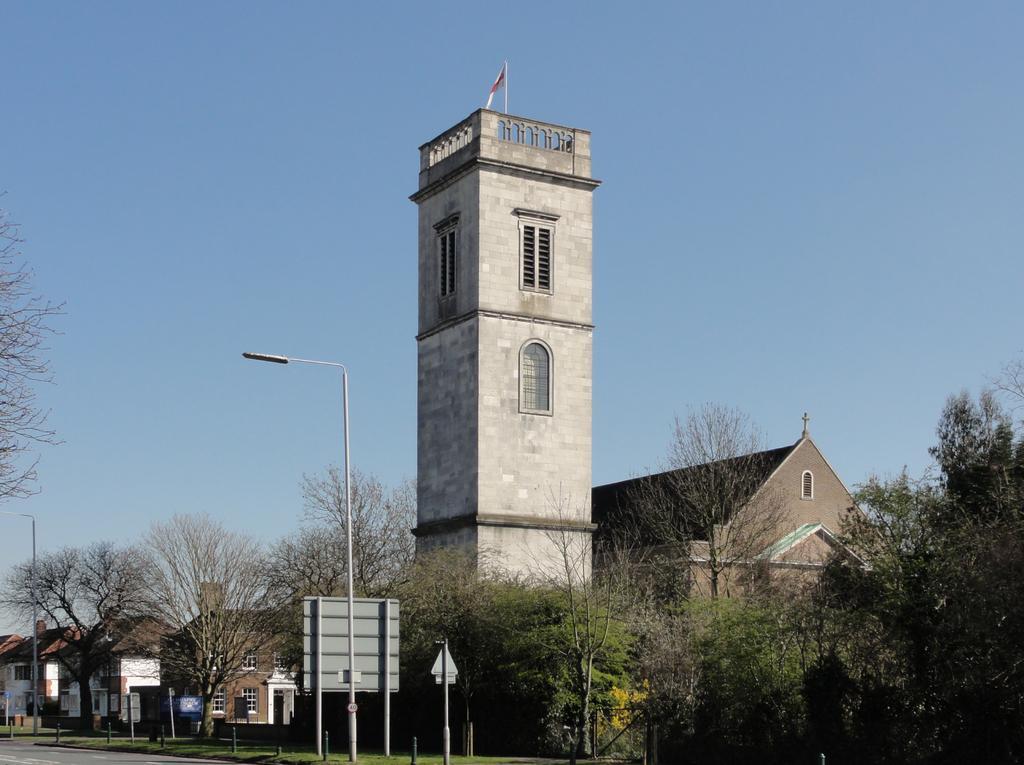Could you give a brief overview of what you see in this image? In this image we can see some buildings, trees, poles and other objects. On the left side bottom of the image there is the floor. On the left side top of the image it looks like a tree. In the background of the image there is the sky. 